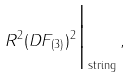Convert formula to latex. <formula><loc_0><loc_0><loc_500><loc_500>R ^ { 2 } ( D F _ { ( 3 ) } ) ^ { 2 } \Big | _ { \text {string} } \, ,</formula> 